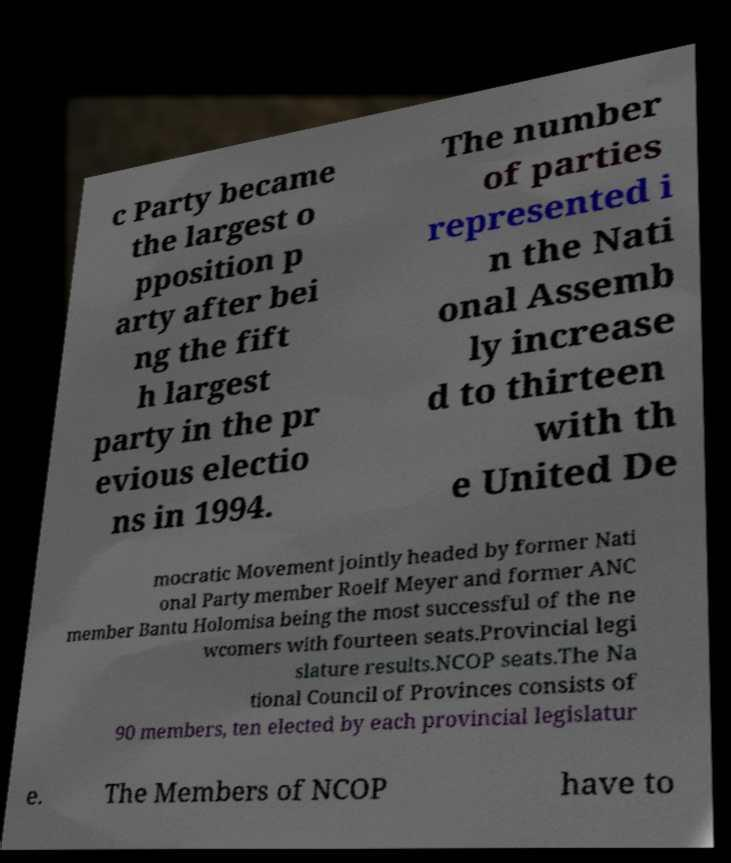I need the written content from this picture converted into text. Can you do that? c Party became the largest o pposition p arty after bei ng the fift h largest party in the pr evious electio ns in 1994. The number of parties represented i n the Nati onal Assemb ly increase d to thirteen with th e United De mocratic Movement jointly headed by former Nati onal Party member Roelf Meyer and former ANC member Bantu Holomisa being the most successful of the ne wcomers with fourteen seats.Provincial legi slature results.NCOP seats.The Na tional Council of Provinces consists of 90 members, ten elected by each provincial legislatur e. The Members of NCOP have to 